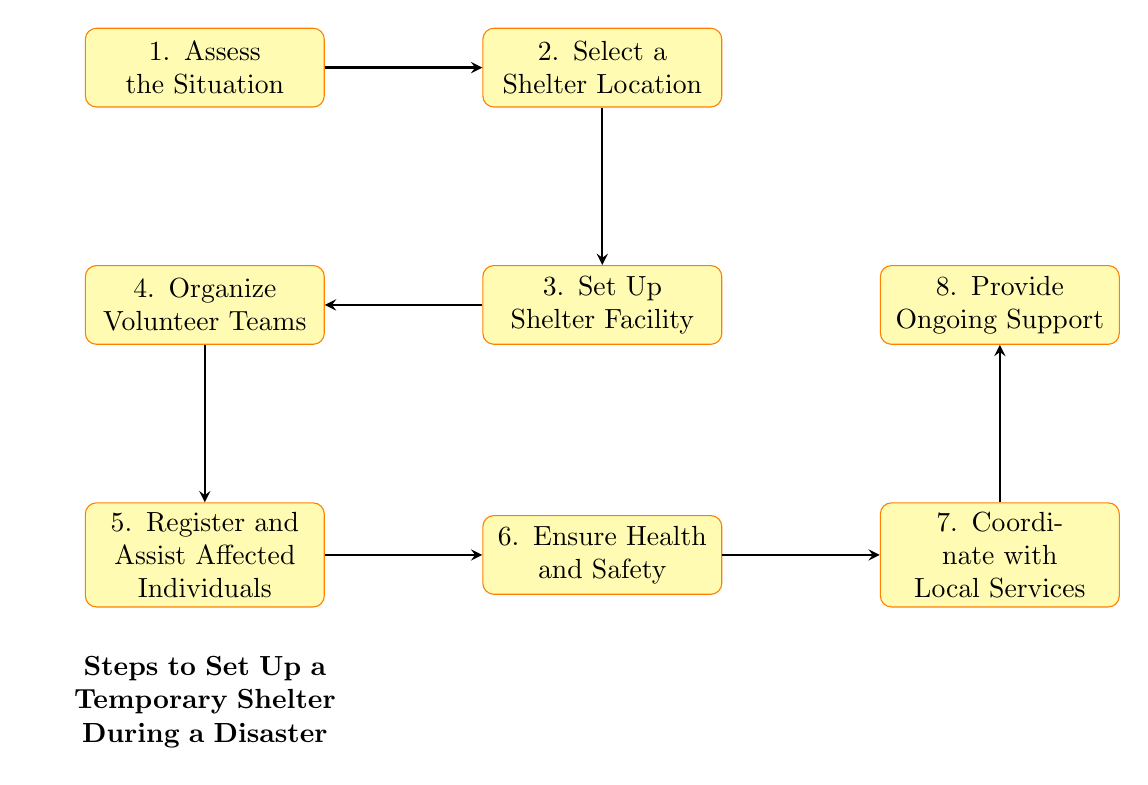What is the first step in setting up a temporary shelter during a disaster? The first step in the flowchart is "Assess the Situation," which is the starting point of the process.
Answer: Assess the Situation How many total steps are there in the flowchart? The flowchart contains a total of eight steps, counting from the first to the last step.
Answer: Eight Who is responsible for organizing volunteer teams? According to the flowchart, "Red Cross Volunteer Leaders" are designated as responsible for organizing volunteer teams.
Answer: Red Cross Volunteer Leaders What is the last step in the process? The last step mentioned in the flowchart is "Provide Ongoing Support," which concludes the shelter setup process.
Answer: Provide Ongoing Support Which step follows the selection of a shelter location? After "Select a Shelter Location," the next step in the diagram is "Set Up Shelter Facility."
Answer: Set Up Shelter Facility What details are provided for the "Ensure Health and Safety" step? The details for this step highlight the provision of medical aid along with maintaining hygiene and sanitation, as represented in the diagram.
Answer: Provide medical aid, maintain hygiene and sanitation What do "Local Authorities & Red Cross Coordinators" coordinate with? They coordinate with "Local Services," as indicated in the flowchart after ensuring health and safety.
Answer: Local Services Which step is responsible for registering and assisting affected individuals? The step that entails registration and assistance is "Register and Assist Affected Individuals," which follows the organization of volunteer teams.
Answer: Register and Assist Affected Individuals 